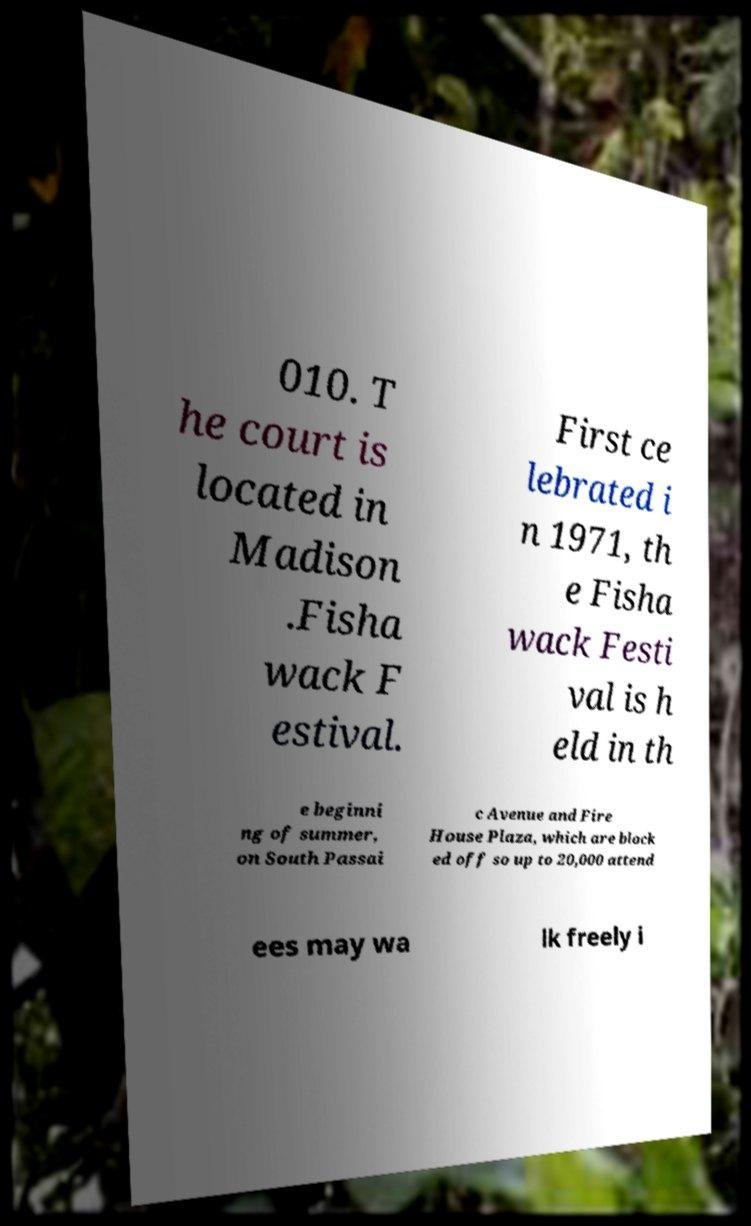Could you extract and type out the text from this image? 010. T he court is located in Madison .Fisha wack F estival. First ce lebrated i n 1971, th e Fisha wack Festi val is h eld in th e beginni ng of summer, on South Passai c Avenue and Fire House Plaza, which are block ed off so up to 20,000 attend ees may wa lk freely i 